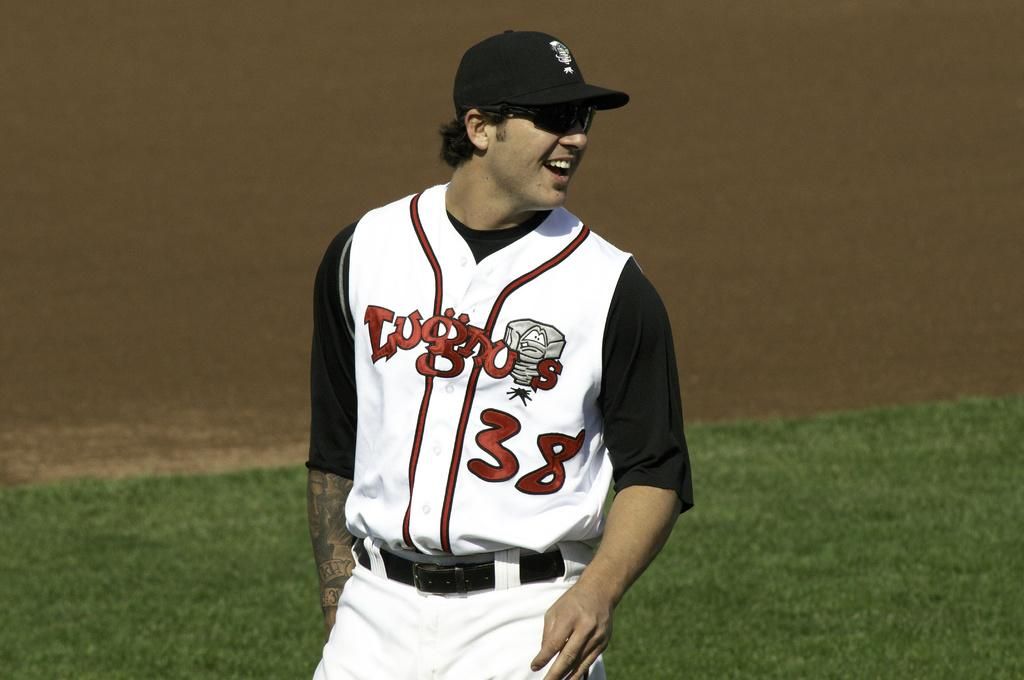Provide a one-sentence caption for the provided image. A baseball player with the number 38 is smiling as he looks back on the field. 